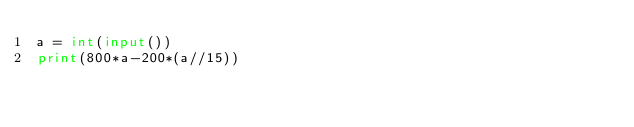Convert code to text. <code><loc_0><loc_0><loc_500><loc_500><_Python_>a = int(input())
print(800*a-200*(a//15))</code> 